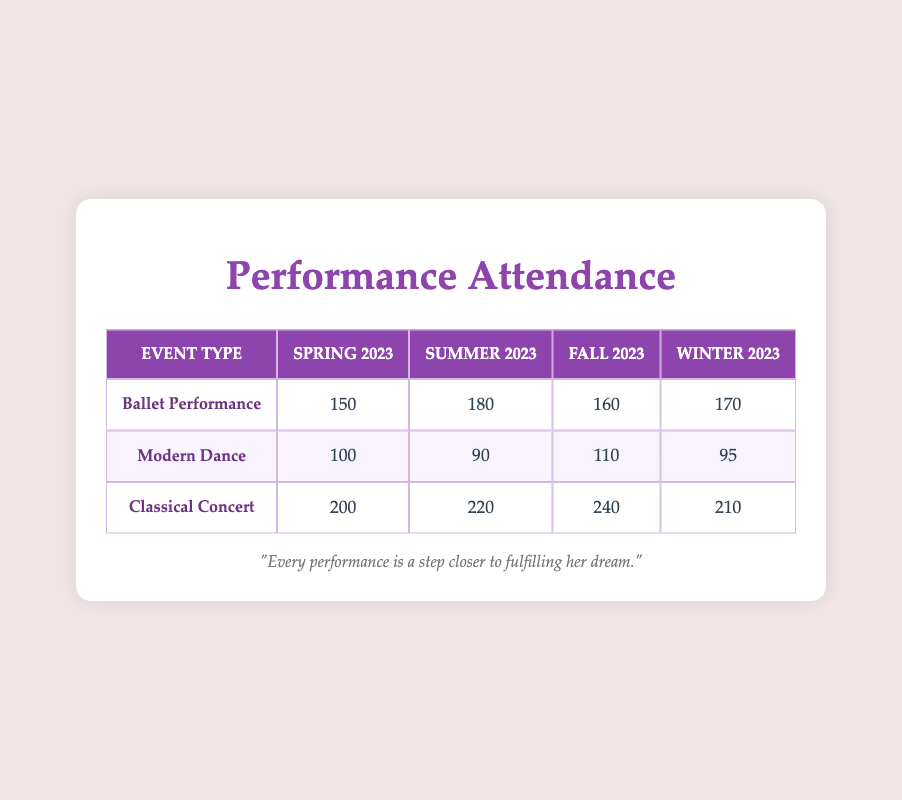What is the total attendance for Ballet Performances in Summer 2023? From the table, the attendance for Ballet Performances in Summer 2023 is 180. Therefore, the total attendance for Ballet Performances in that season is simply 180.
Answer: 180 Which event type had the highest attendance in Fall 2023? According to the table, the attendance numbers for Fall 2023 are: Ballet Performance (160), Modern Dance (110), and Classical Concert (240). The highest among these is 240, which corresponds to the Classical Concert.
Answer: Classical Concert What was the average attendance for Modern Dance across all seasons? The attendances for Modern Dance across the four seasons are: Spring 2023 (100), Summer 2023 (90), Fall 2023 (110), and Winter 2023 (95). First, sum these values: 100 + 90 + 110 + 95 = 395. Then, divide by the number of seasons (4): 395 / 4 = 98.75.
Answer: 98.75 Did the attendance for Classical Concert increase every season from Spring 2023 to Fall 2023? The attendance for Classical Concert is 200 in Spring, 220 in Summer, 240 in Fall, and 210 in Winter. Analyzing these numbers shows that attendance increased from Spring to Summer (200 to 220) and from Summer to Fall (220 to 240) but decreased from Fall to Winter (240 to 210). Hence, the attendance did not increase every season.
Answer: No Which event type had the lowest attendance in Winter 2023? According to the table, the attendances for Winter 2023 are: Ballet Performance (170), Modern Dance (95), and Classical Concert (210). Among these, Modern Dance has the lowest attendance figure at 95.
Answer: Modern Dance What is the total attendance for all events in Spring 2023? The attendances for Spring 2023 are: Ballet Performance (150), Modern Dance (100), and Classical Concert (200). To find the total, sum these values: 150 + 100 + 200 = 450.
Answer: 450 In which season did the Ballet Performance see the highest attendance? Looking at the attendance values for Ballet Performances, we find: Spring 2023 (150), Summer 2023 (180), Fall 2023 (160), and Winter 2023 (170). The highest attendance was recorded in Summer 2023, at 180.
Answer: Summer 2023 Was the attendance for Modern Dance in Spring 2023 greater than the attendance in Winter 2023? In Spring 2023, Modern Dance had an attendance of 100, while in Winter 2023, it had 95. Since 100 is greater than 95, the attendance in Spring 2023 was indeed greater.
Answer: Yes 